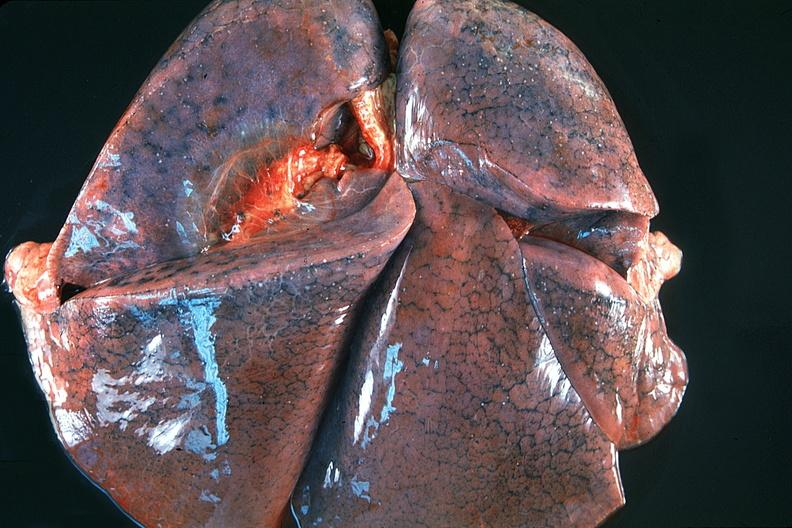what is present?
Answer the question using a single word or phrase. Respiratory 